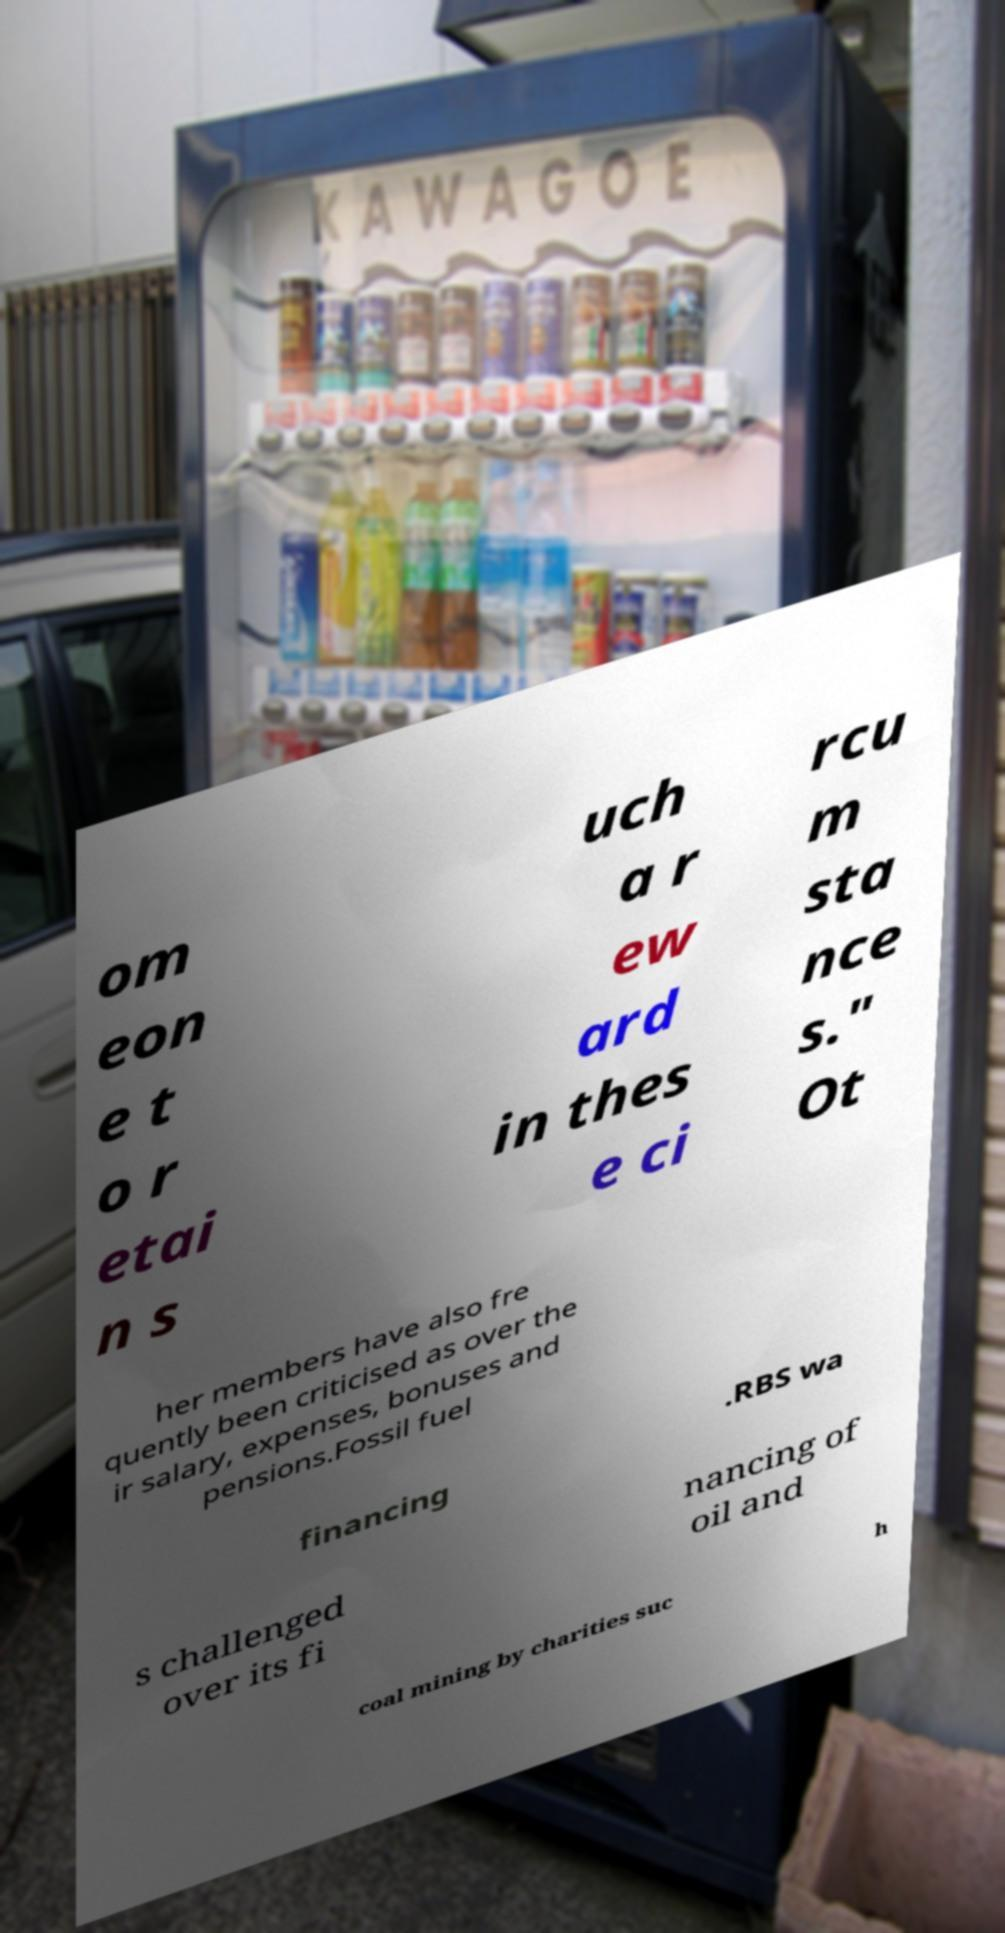Can you accurately transcribe the text from the provided image for me? om eon e t o r etai n s uch a r ew ard in thes e ci rcu m sta nce s." Ot her members have also fre quently been criticised as over the ir salary, expenses, bonuses and pensions.Fossil fuel financing .RBS wa s challenged over its fi nancing of oil and coal mining by charities suc h 